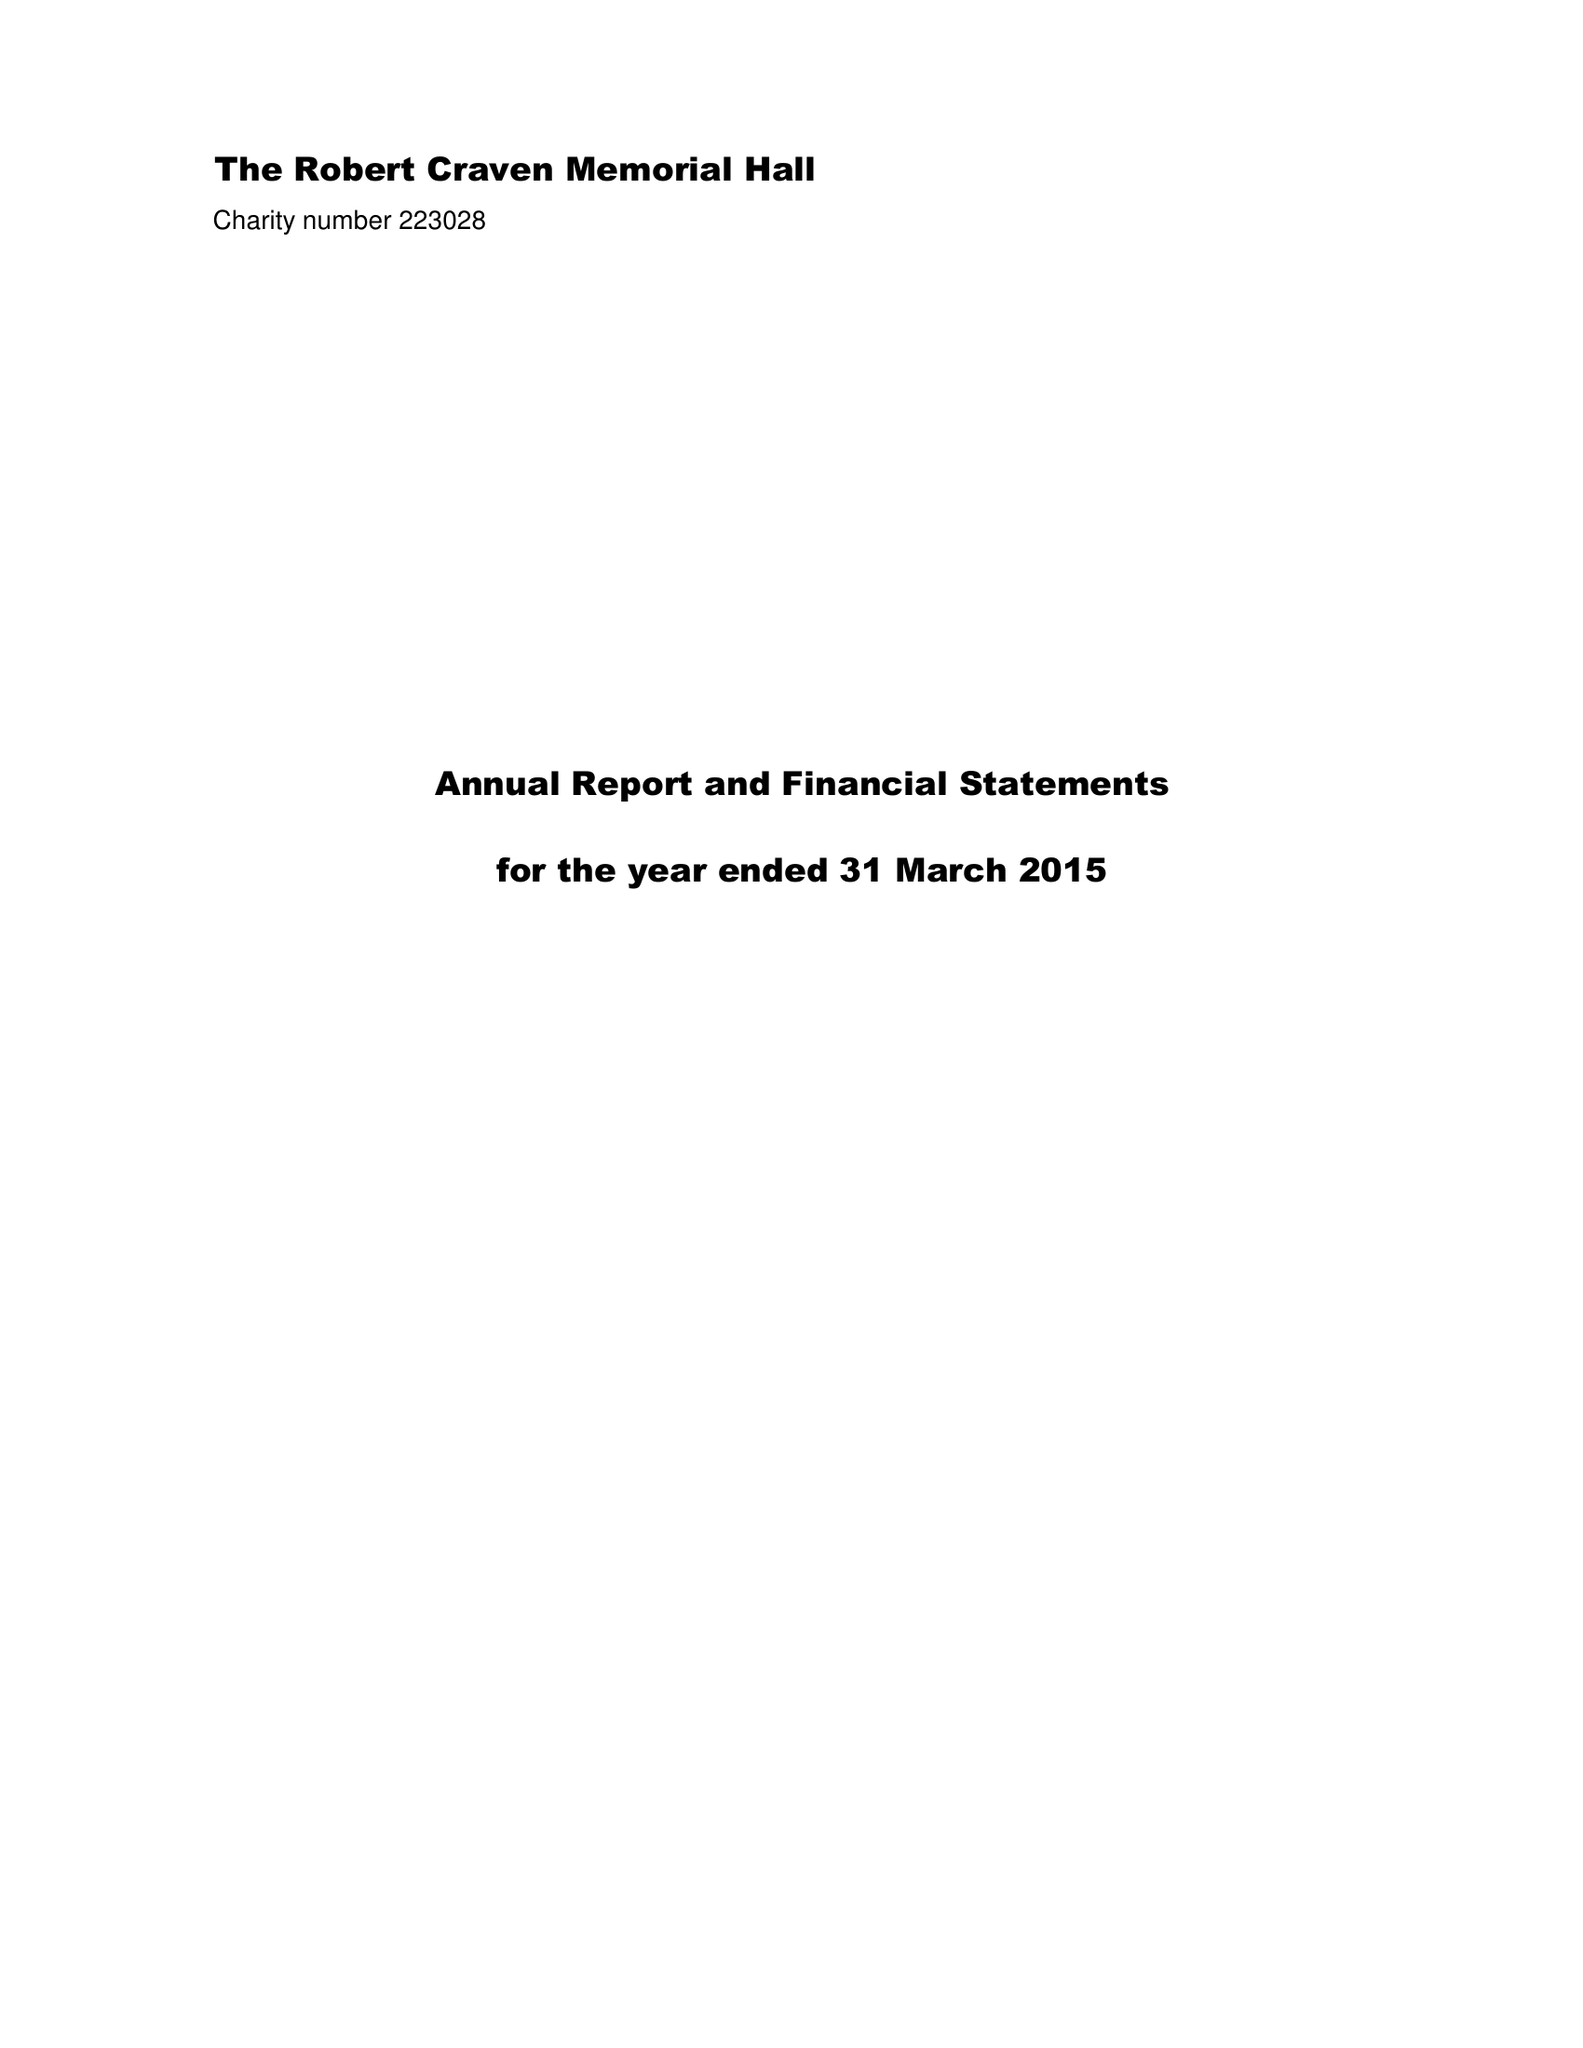What is the value for the income_annually_in_british_pounds?
Answer the question using a single word or phrase. 40080.00 